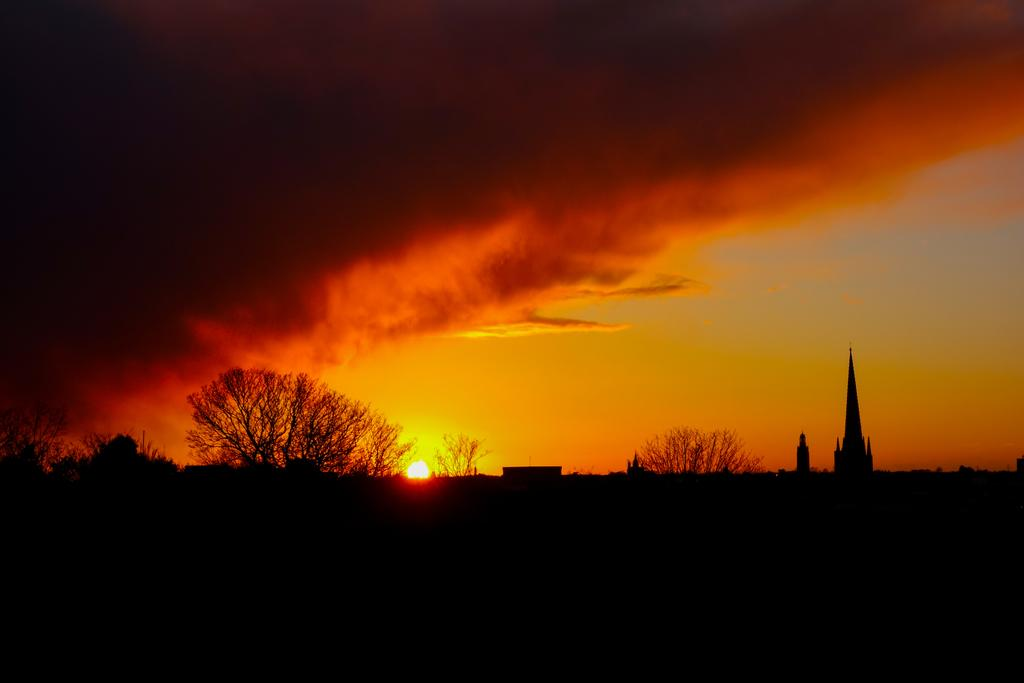What event is taking place in the sky in the image? The image depicts a sunrise in the sky. What can be seen in the middle of the image? There are trees in the middle of the image. What type of structure is being constructed on the right side of the image? There appears to be a cathedral construction on the right side of the image. Can you see a boot supporting the cathedral construction in the image? There is no boot present in the image, nor is there any support visible for the cathedral construction. 